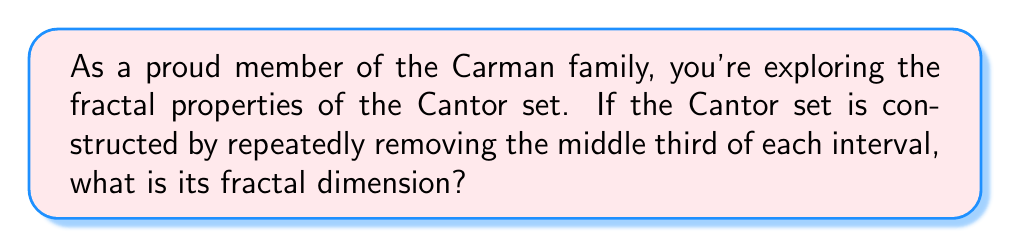What is the answer to this math problem? Let's approach this step-by-step:

1) The Cantor set is constructed by iteratively removing the middle third of each interval. In each iteration:
   - We start with 1 interval
   - We end up with 2 intervals
   - Each new interval is 1/3 the size of the previous interval

2) To calculate the fractal dimension, we use the formula:
   
   $$D = \frac{\log N}{\log (1/r)}$$

   Where:
   $D$ = fractal dimension
   $N$ = number of self-similar pieces
   $r$ = scaling factor

3) In our case:
   $N = 2$ (we get 2 new intervals in each iteration)
   $r = 1/3$ (each new interval is 1/3 the size of the previous)

4) Plugging these values into our formula:

   $$D = \frac{\log 2}{\log (1/(1/3))} = \frac{\log 2}{\log 3}$$

5) To calculate this:
   
   $$D = \frac{\log 2}{\log 3} \approx 0.6309$$

6) The exact value is the irrational number $\frac{\log 2}{\log 3}$, but it's often approximated to 0.6309.
Answer: $\frac{\log 2}{\log 3}$ 